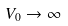<formula> <loc_0><loc_0><loc_500><loc_500>V _ { 0 } \rightarrow \infty</formula> 